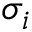Convert formula to latex. <formula><loc_0><loc_0><loc_500><loc_500>\sigma _ { i }</formula> 